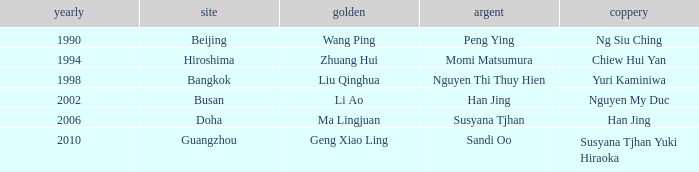What silver possesses a golf of li ao? Han Jing. 